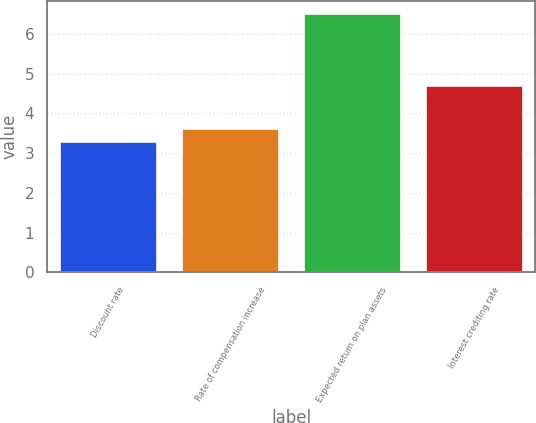Convert chart to OTSL. <chart><loc_0><loc_0><loc_500><loc_500><bar_chart><fcel>Discount rate<fcel>Rate of compensation increase<fcel>Expected return on plan assets<fcel>Interest crediting rate<nl><fcel>3.29<fcel>3.61<fcel>6.5<fcel>4.69<nl></chart> 